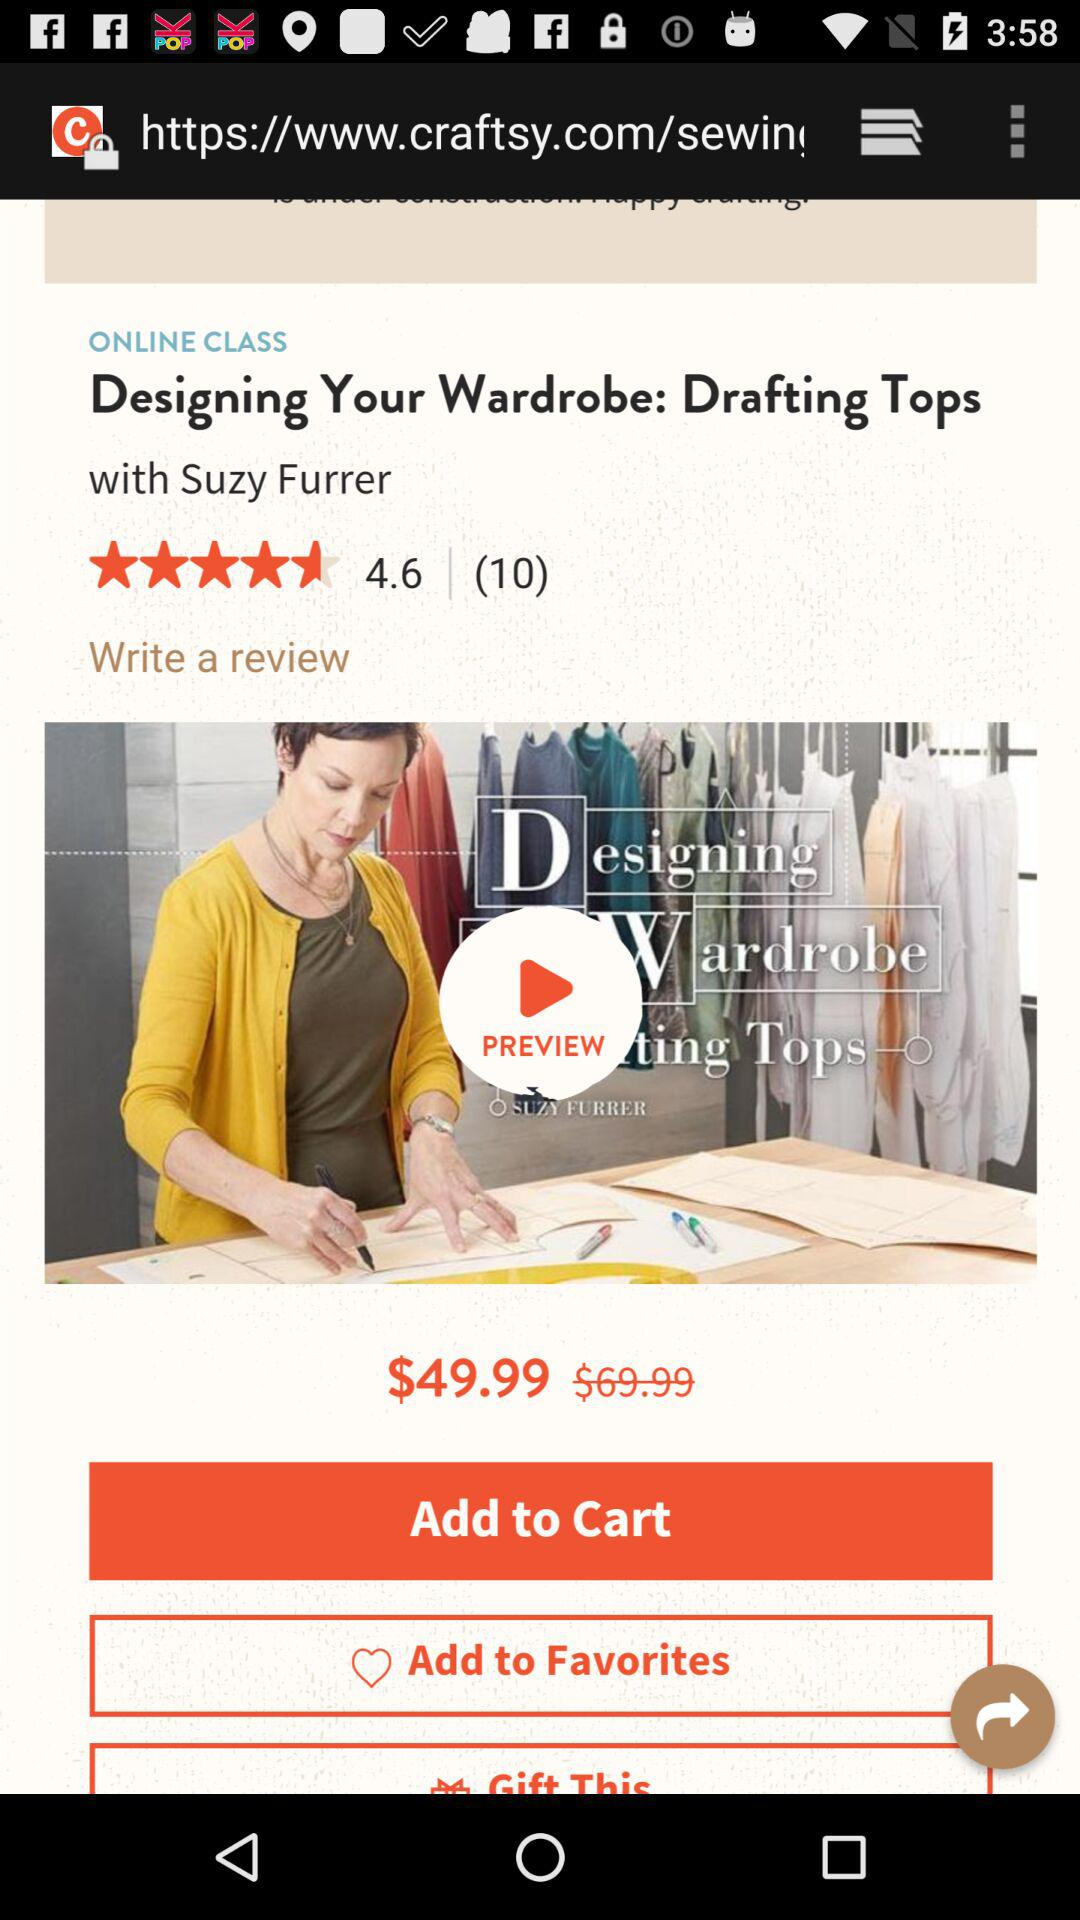How many ratings are there in this? There are 4.6 ratings. 